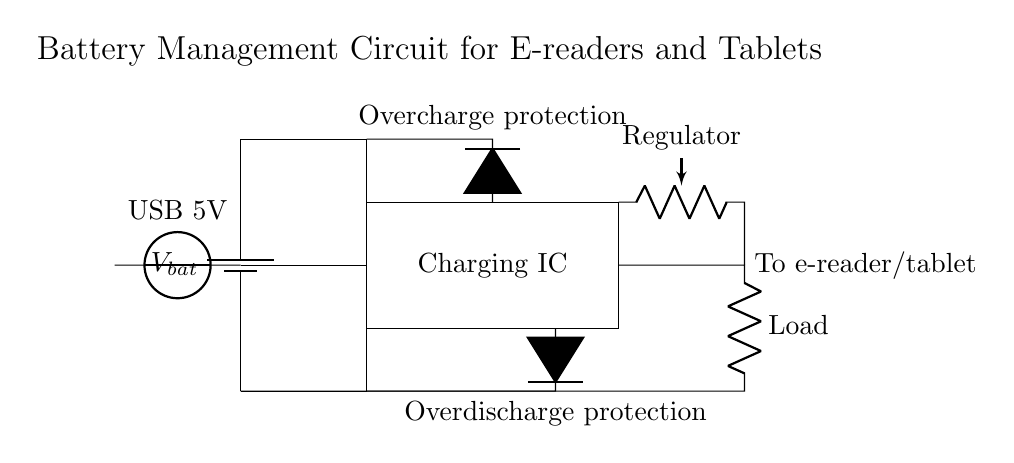What component connects the USB input to the battery? The circuit shows a direct connection from the USB input to the battery, indicating it's connecting the power supply to charge the battery.
Answer: Battery What type of protection circuit is indicated at the top? The circuit indicates overcharge protection, which prevents the battery from being overcharged during charging processes.
Answer: Overcharge protection What is the purpose of the charging IC in this circuit? The charging IC is responsible for controlling the charging process of the battery, ensuring it receives the correct voltage and current for safe charging.
Answer: Charging control What role does the regulator play in this circuit? The regulator ensures the voltage supplied to the load is stable, keeping it within a specific range that the e-reader or tablet can safely use.
Answer: Voltage regulation How many diodes are present in the circuit? There are two diodes shown in the circuit, one for overcharge protection and one for overdischarge protection, serving safety functions for the battery.
Answer: Two What voltage is supplied by the USB? The voltage from the USB input is specified as five volts, which is the standard output for USB connections.
Answer: Five volts What is the load connected to the output? The load connected at the output is labeled as "Load," which represents the e-reader or tablet that is being powered by the battery management circuit.
Answer: Load 